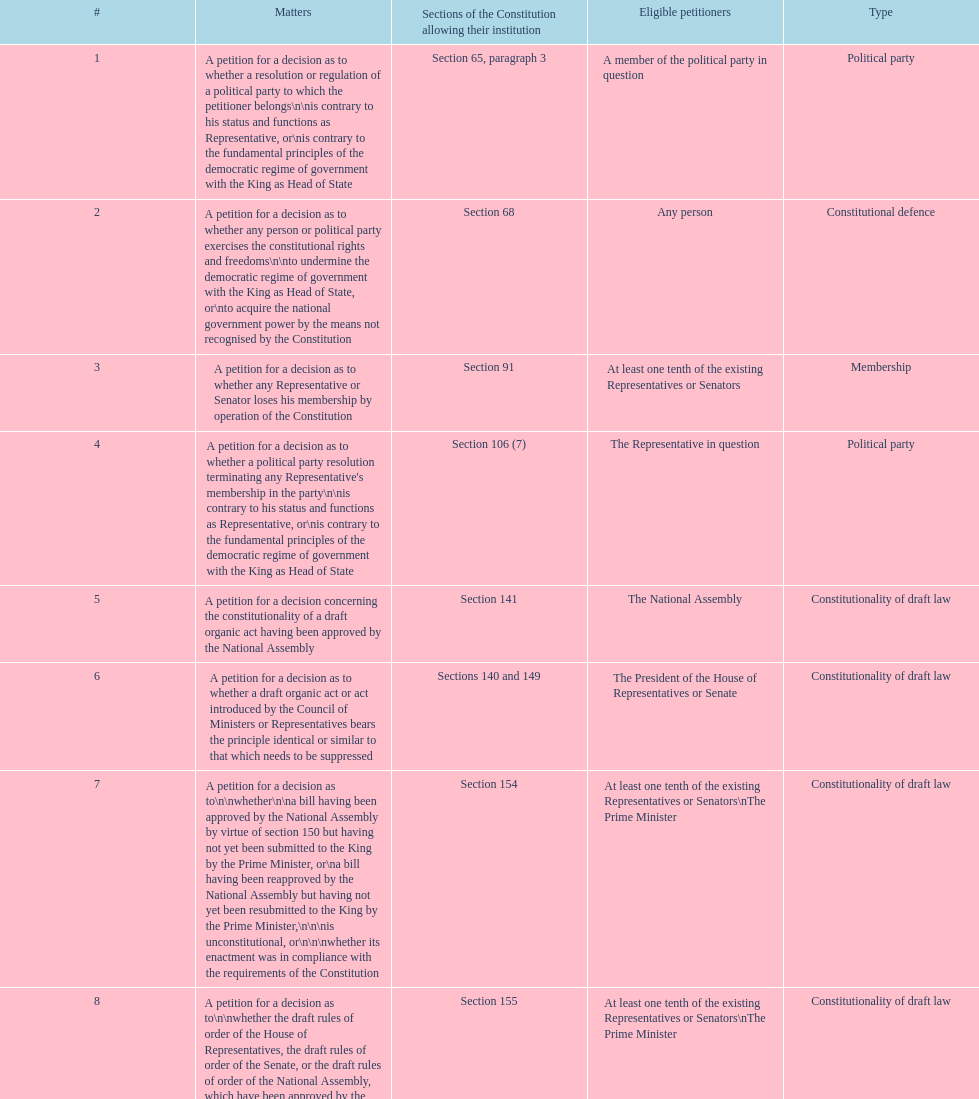True or false: any person has the ability to request concerns 2 and 17? True. 